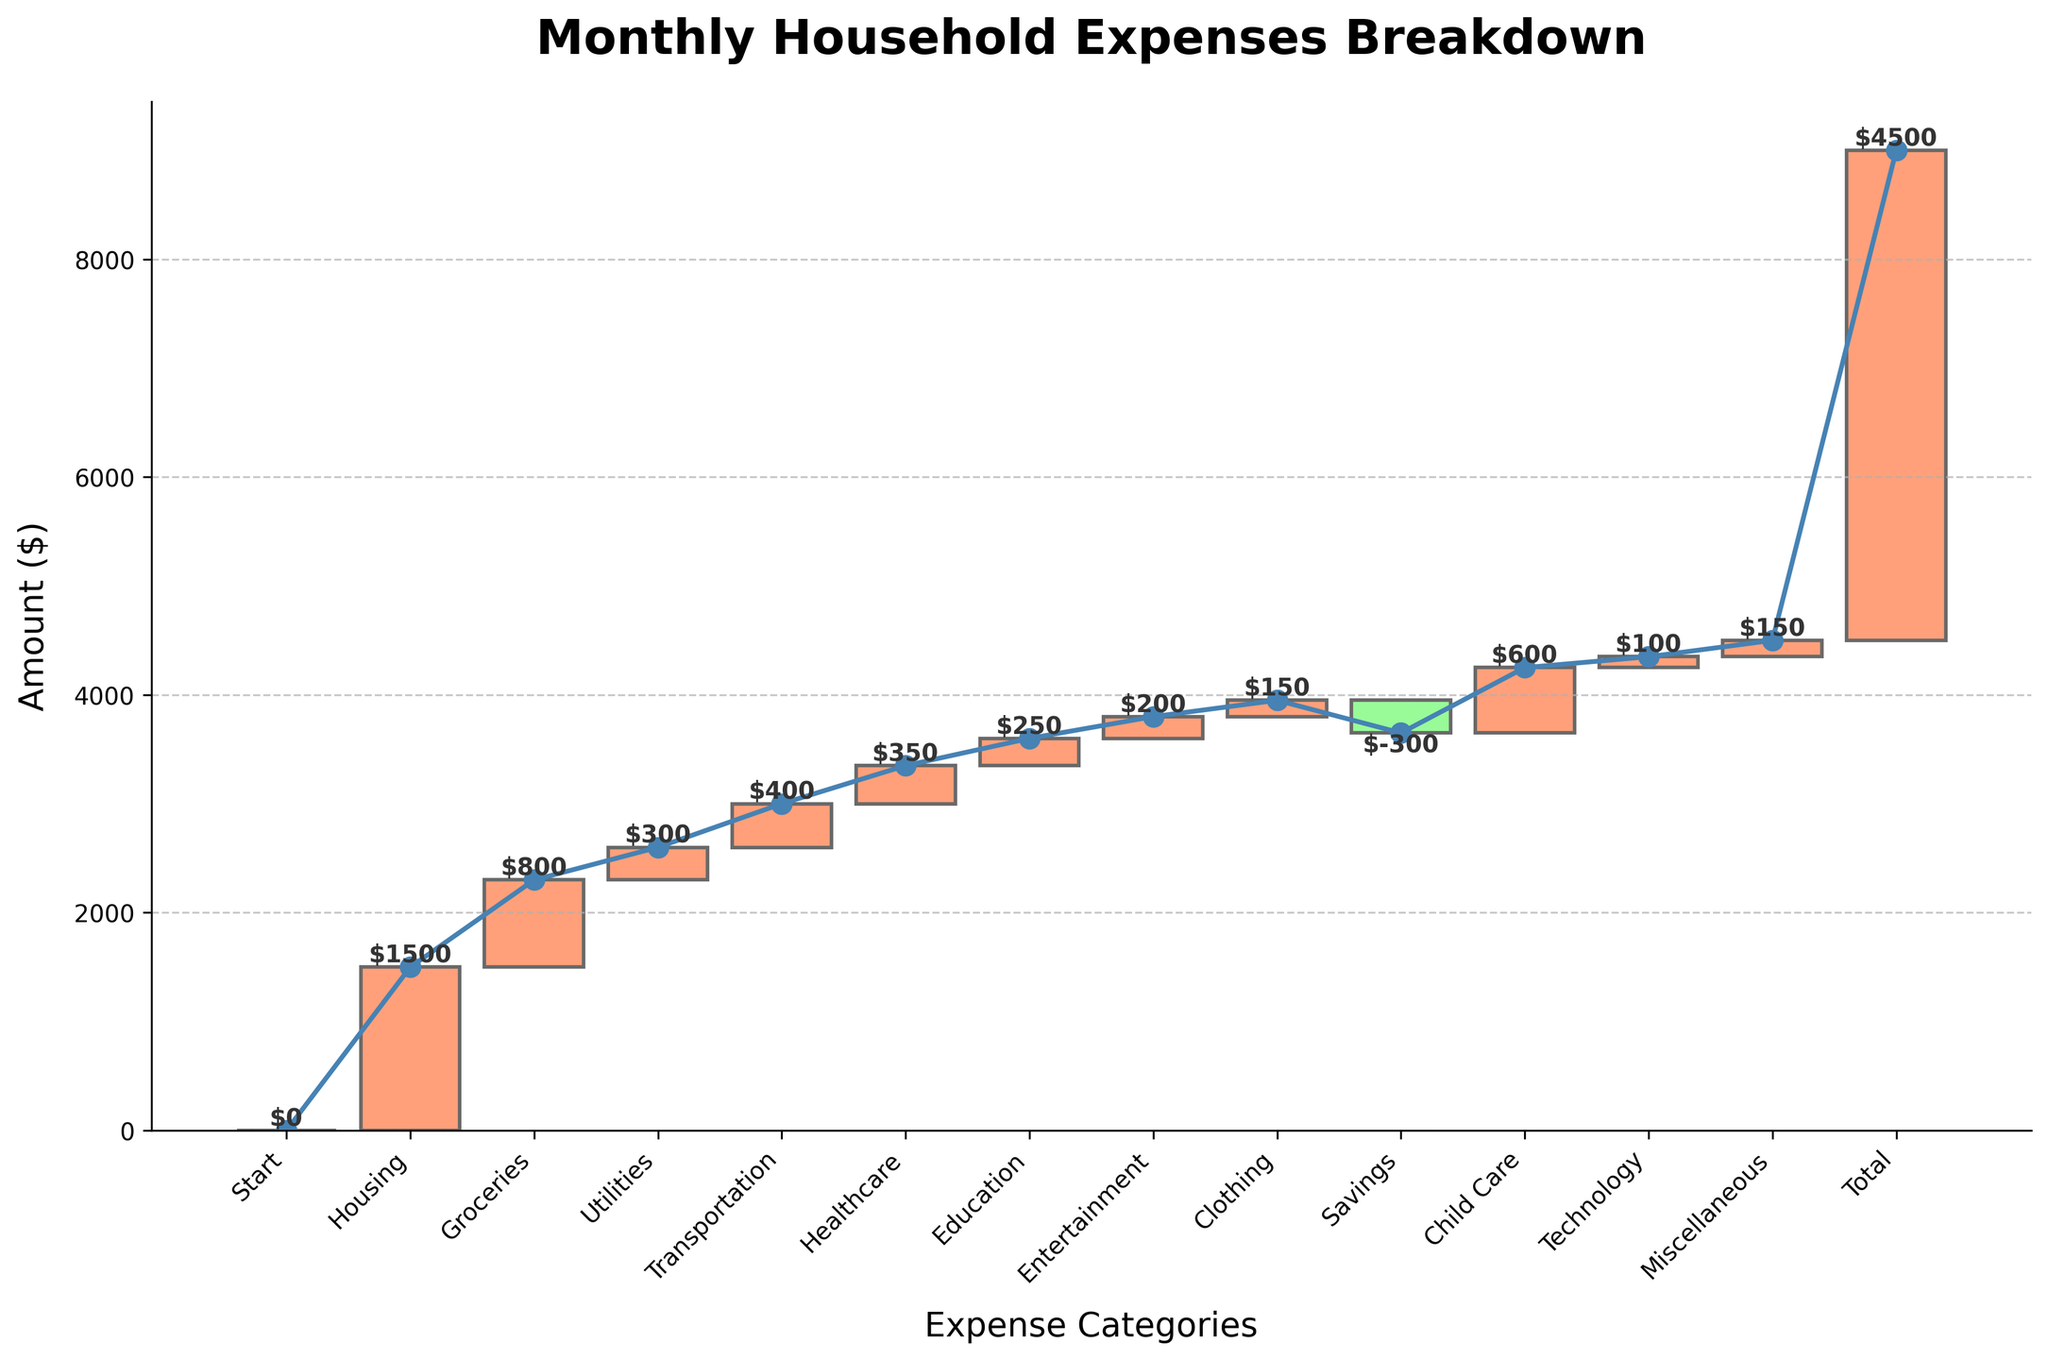What is the title of the plot? The title is usually displayed at the top of the plot. In this case, it clearly states, "Monthly Household Expenses Breakdown".
Answer: Monthly Household Expenses Breakdown What is the total monthly household expense? The total is typically highlighted at the end of the waterfall chart. The total amount listed is $4500.
Answer: $4500 What color represents expense increases? On the waterfall chart, positive values are usually highlighted in a distinguishing color, which in this plot are the orange(#FFA07A) bars.
Answer: Orange Which category has the highest expense? The highest bar among the expenses represents the largest category. The "Housing" category is the tallest, indicating the highest expense at $1500.
Answer: Housing How much is spent on Transportation and Child Care combined? Add the amounts for Transportation ($400) and Child Care ($600). $400 + $600 = $1000.
Answer: $1000 Which categories show a decrease? Categories with negative values typically decrease, shown in green bars on this plot. Savings is the one with a negative value, -$300.
Answer: Savings How much more is spent on Housing than on Groceries? Subtract the Groceries expense from the Housing expense. $1500 (Housing) - $800 (Groceries) = $700.
Answer: $700 Which expense category is exactly halfway in the sequence? Count the categories from the start to the total, halfway would be around the middle point. In order: (1) Housing, (2) Groceries, (3) Utilities, (4) Transportation, (5) Healthcare, (6) Education, (7) Entertainment (halfway).
Answer: Entertainment What is the net effect of Savings on the total expenses? Savings are subtracted from the total. Here, Savings have a value of -$300.
Answer: -$300 How does the cumulative expense trend move throughout the chart? The cumulative sum typically follows the line added in the waterfall plot. It increases steadily with each addition, peaks until overspending categories, here up to the final total of $4500, with a downward deviation at Savings.
Answer: Upward Is the amount spent on Technology higher or lower than on Clothing? Compare the amounts for Technology ($100) with Clothing ($150). Technology has a lower amount.
Answer: Lower 